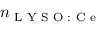<formula> <loc_0><loc_0><loc_500><loc_500>n _ { L Y S O \colon C e }</formula> 